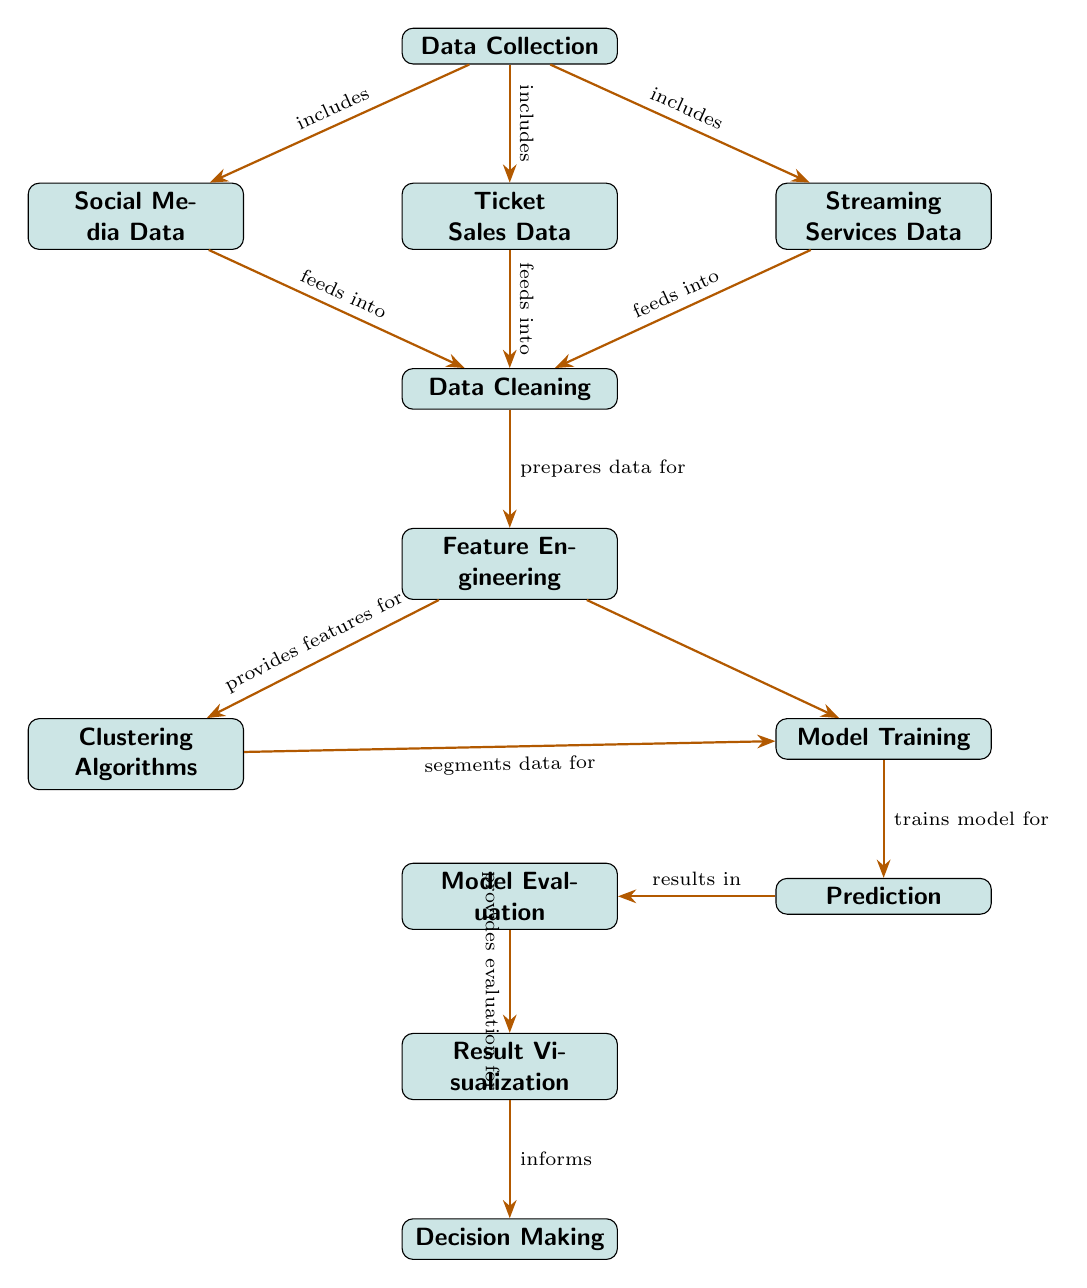What are the three data sources mentioned in the diagram? The diagram lists three data sources as nodes connected to the "Data Collection" node, which are "Social Media Data," "Ticket Sales Data," and "Streaming Services Data."
Answer: Social Media Data, Ticket Sales Data, Streaming Services Data Which node comes right before "Feature Engineering"? The "Data Cleaning" node directly leads into the "Feature Engineering" node according to the flow of the diagram.
Answer: Data Cleaning How many nodes are there in total? Counting all the nodes listed in the diagram, we have eleven nodes in total: "Data Collection," "Social Media Data," "Ticket Sales Data," "Streaming Services Data," "Data Cleaning," "Feature Engineering," "Clustering Algorithms," "Model Training," "Prediction," "Model Evaluation," "Result Visualization," and "Decision Making."
Answer: Eleven What process directly follows "Model Training"? The "Prediction" node comes directly after "Model Training" as indicated by the arrow connecting the two nodes.
Answer: Prediction Which node informs the "Decision Making" process? The "Result Visualization" node provides the necessary information that informs the "Decision Making" node, as shown in the diagram's flow.
Answer: Result Visualization What do "Clustering Algorithms" segment data for? "Clustering Algorithms" segment data specifically for "Model Training," as indicated by the directed edge from "Clustering Algorithms" to "Model Training."
Answer: Model Training What type of data does "Data Cleaning" prepare for? The "Data Cleaning" node prepares data specifically for "Feature Engineering," as indicated by the arrow in the diagram.
Answer: Feature Engineering What is the last step in this machine learning process according to the diagram? The last step is "Decision Making," which comes after "Result Visualization" in the process outlined in the diagram.
Answer: Decision Making 